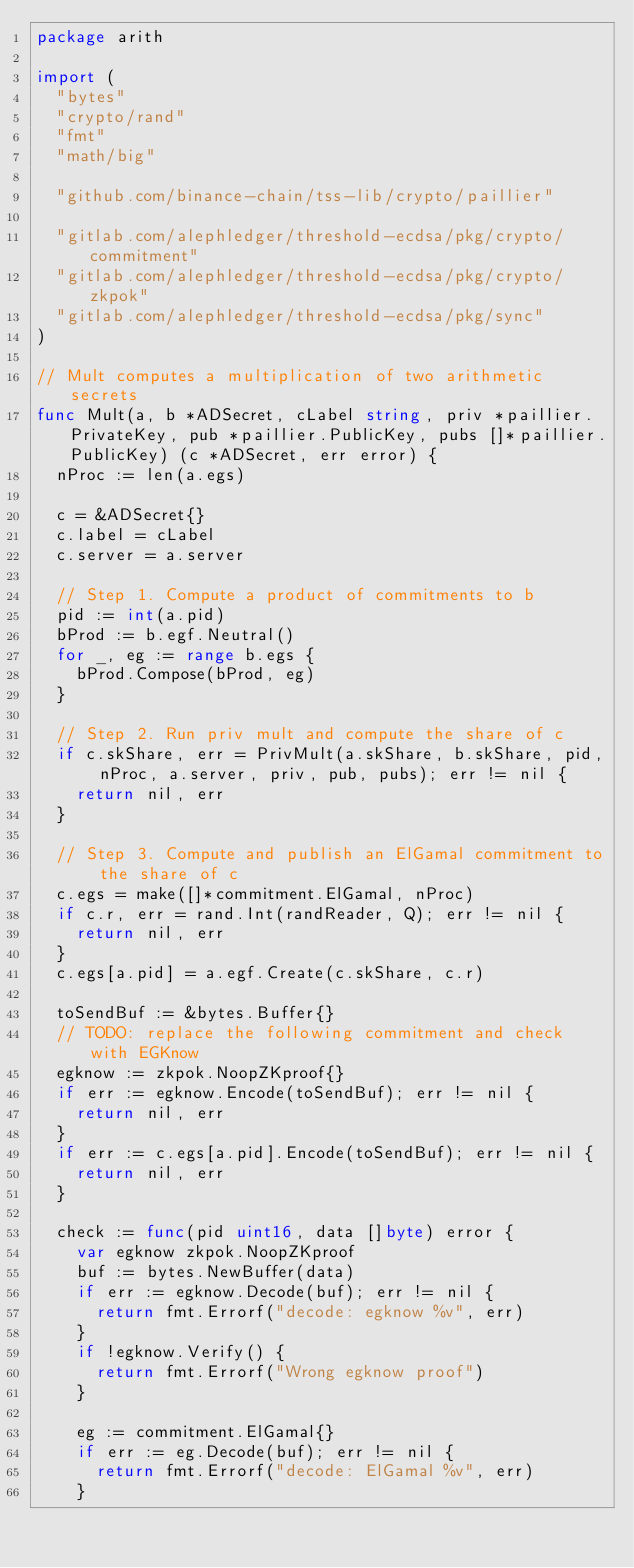<code> <loc_0><loc_0><loc_500><loc_500><_Go_>package arith

import (
	"bytes"
	"crypto/rand"
	"fmt"
	"math/big"

	"github.com/binance-chain/tss-lib/crypto/paillier"

	"gitlab.com/alephledger/threshold-ecdsa/pkg/crypto/commitment"
	"gitlab.com/alephledger/threshold-ecdsa/pkg/crypto/zkpok"
	"gitlab.com/alephledger/threshold-ecdsa/pkg/sync"
)

// Mult computes a multiplication of two arithmetic secrets
func Mult(a, b *ADSecret, cLabel string, priv *paillier.PrivateKey, pub *paillier.PublicKey, pubs []*paillier.PublicKey) (c *ADSecret, err error) {
	nProc := len(a.egs)

	c = &ADSecret{}
	c.label = cLabel
	c.server = a.server

	// Step 1. Compute a product of commitments to b
	pid := int(a.pid)
	bProd := b.egf.Neutral()
	for _, eg := range b.egs {
		bProd.Compose(bProd, eg)
	}

	// Step 2. Run priv mult and compute the share of c
	if c.skShare, err = PrivMult(a.skShare, b.skShare, pid, nProc, a.server, priv, pub, pubs); err != nil {
		return nil, err
	}

	// Step 3. Compute and publish an ElGamal commitment to the share of c
	c.egs = make([]*commitment.ElGamal, nProc)
	if c.r, err = rand.Int(randReader, Q); err != nil {
		return nil, err
	}
	c.egs[a.pid] = a.egf.Create(c.skShare, c.r)

	toSendBuf := &bytes.Buffer{}
	// TODO: replace the following commitment and check with EGKnow
	egknow := zkpok.NoopZKproof{}
	if err := egknow.Encode(toSendBuf); err != nil {
		return nil, err
	}
	if err := c.egs[a.pid].Encode(toSendBuf); err != nil {
		return nil, err
	}

	check := func(pid uint16, data []byte) error {
		var egknow zkpok.NoopZKproof
		buf := bytes.NewBuffer(data)
		if err := egknow.Decode(buf); err != nil {
			return fmt.Errorf("decode: egknow %v", err)
		}
		if !egknow.Verify() {
			return fmt.Errorf("Wrong egknow proof")
		}

		eg := commitment.ElGamal{}
		if err := eg.Decode(buf); err != nil {
			return fmt.Errorf("decode: ElGamal %v", err)
		}
</code> 